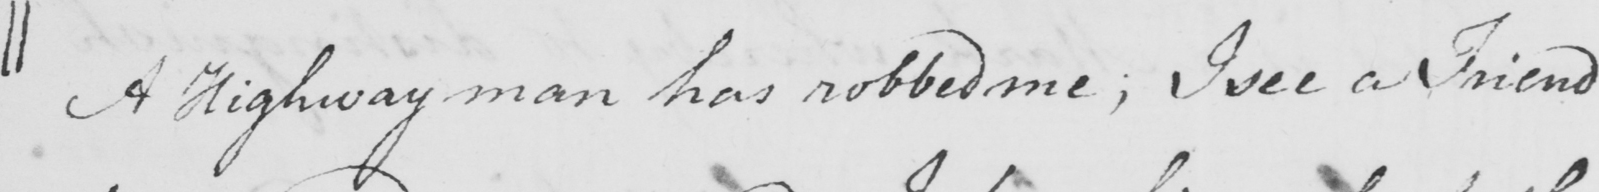Please provide the text content of this handwritten line. || A Highway man has robbed me ; I see a Friend 